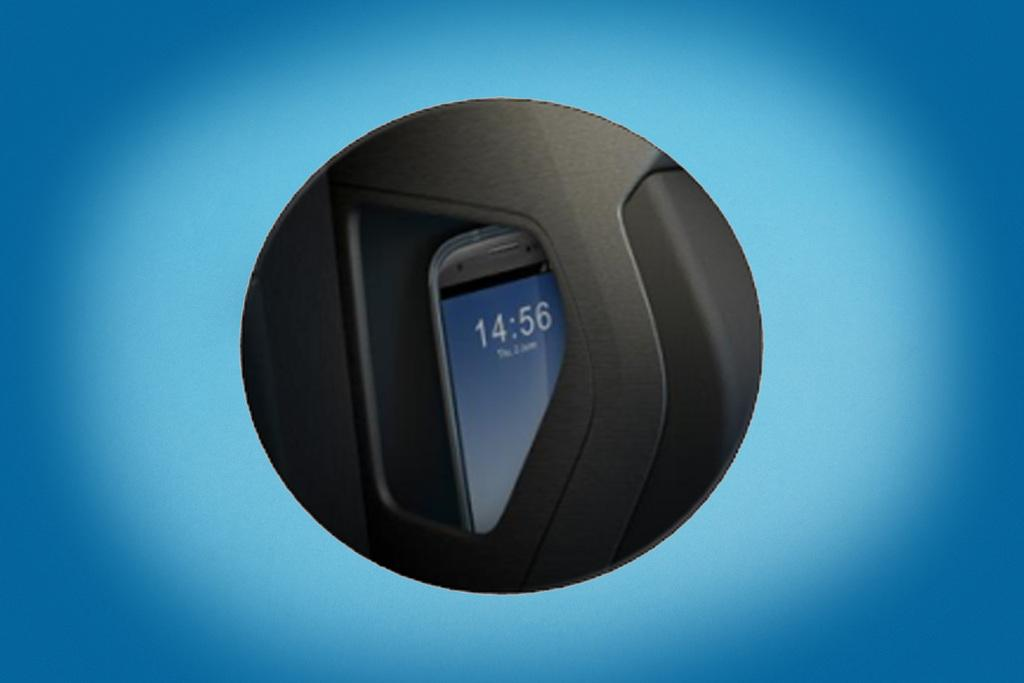<image>
Describe the image concisely. Part of a phone that reads 14:56 on the screen. 